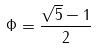<formula> <loc_0><loc_0><loc_500><loc_500>\Phi = \frac { \sqrt { 5 } - 1 } { 2 }</formula> 